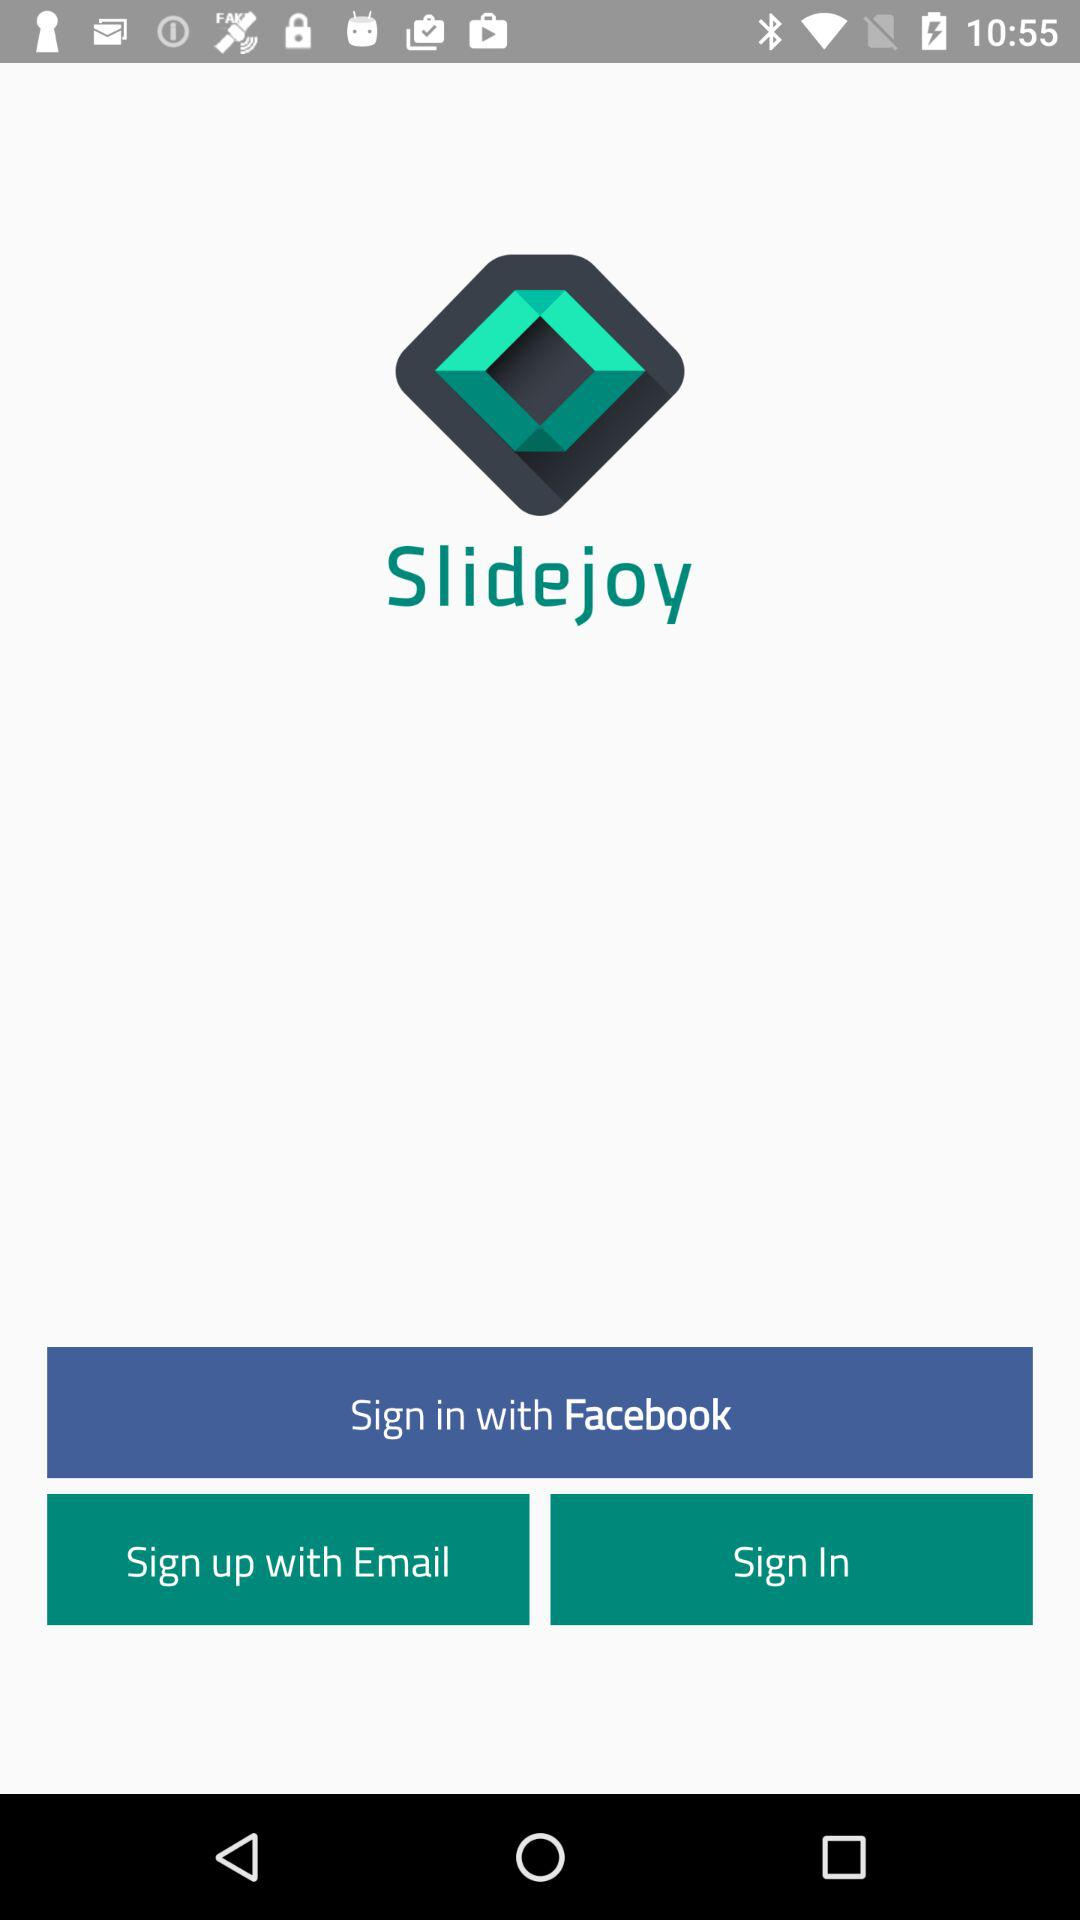What is the name of the application? The name of the application is "Slidejoy". 